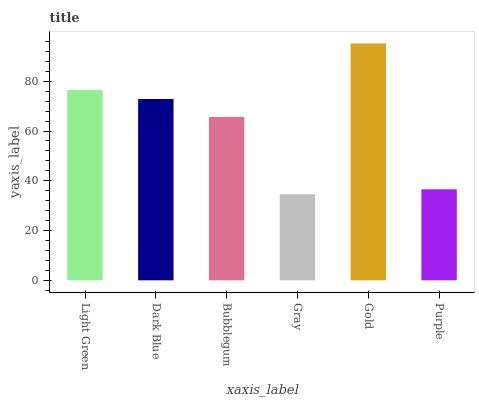Is Gray the minimum?
Answer yes or no. Yes. Is Gold the maximum?
Answer yes or no. Yes. Is Dark Blue the minimum?
Answer yes or no. No. Is Dark Blue the maximum?
Answer yes or no. No. Is Light Green greater than Dark Blue?
Answer yes or no. Yes. Is Dark Blue less than Light Green?
Answer yes or no. Yes. Is Dark Blue greater than Light Green?
Answer yes or no. No. Is Light Green less than Dark Blue?
Answer yes or no. No. Is Dark Blue the high median?
Answer yes or no. Yes. Is Bubblegum the low median?
Answer yes or no. Yes. Is Bubblegum the high median?
Answer yes or no. No. Is Dark Blue the low median?
Answer yes or no. No. 